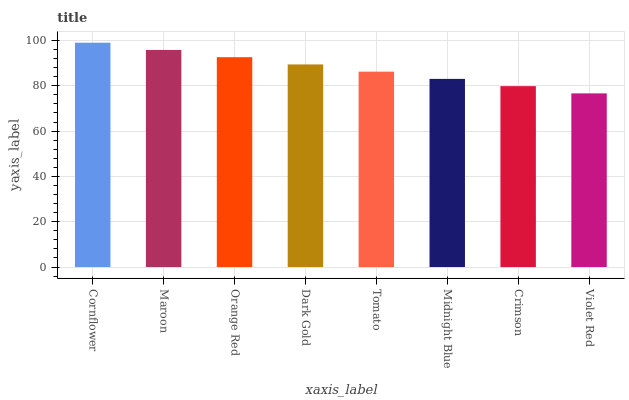Is Violet Red the minimum?
Answer yes or no. Yes. Is Cornflower the maximum?
Answer yes or no. Yes. Is Maroon the minimum?
Answer yes or no. No. Is Maroon the maximum?
Answer yes or no. No. Is Cornflower greater than Maroon?
Answer yes or no. Yes. Is Maroon less than Cornflower?
Answer yes or no. Yes. Is Maroon greater than Cornflower?
Answer yes or no. No. Is Cornflower less than Maroon?
Answer yes or no. No. Is Dark Gold the high median?
Answer yes or no. Yes. Is Tomato the low median?
Answer yes or no. Yes. Is Tomato the high median?
Answer yes or no. No. Is Midnight Blue the low median?
Answer yes or no. No. 